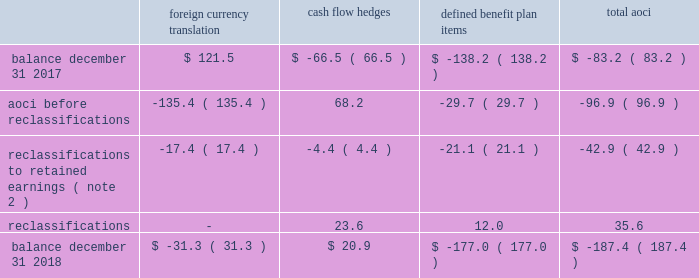Zimmer biomet holdings , inc .
And subsidiaries 2018 form 10-k annual report notes to consolidated financial statements ( continued ) default for unsecured financing arrangements , including , among other things , limitations on consolidations , mergers and sales of assets .
Financial covenants under the 2018 , 2016 and 2014 credit agreements include a consolidated indebtedness to consolidated ebitda ratio of no greater than 5.0 to 1.0 through june 30 , 2017 , and no greater than 4.5 to 1.0 thereafter .
If our credit rating falls below investment grade , additional restrictions would result , including restrictions on investments and payment of dividends .
We were in compliance with all covenants under the 2018 , 2016 and 2014 credit agreements as of december 31 , 2018 .
As of december 31 , 2018 , there were no borrowings outstanding under the multicurrency revolving facility .
We may , at our option , redeem our senior notes , in whole or in part , at any time upon payment of the principal , any applicable make-whole premium , and accrued and unpaid interest to the date of redemption , except that the floating rate notes due 2021 may not be redeemed until on or after march 20 , 2019 and such notes do not have any applicable make-whole premium .
In addition , we may redeem , at our option , the 2.700% ( 2.700 % ) senior notes due 2020 , the 3.375% ( 3.375 % ) senior notes due 2021 , the 3.150% ( 3.150 % ) senior notes due 2022 , the 3.700% ( 3.700 % ) senior notes due 2023 , the 3.550% ( 3.550 % ) senior notes due 2025 , the 4.250% ( 4.250 % ) senior notes due 2035 and the 4.450% ( 4.450 % ) senior notes due 2045 without any make-whole premium at specified dates ranging from one month to six months in advance of the scheduled maturity date .
The estimated fair value of our senior notes as of december 31 , 2018 , based on quoted prices for the specific securities from transactions in over-the-counter markets ( level 2 ) , was $ 7798.9 million .
The estimated fair value of japan term loan a and japan term loan b , in the aggregate , as of december 31 , 2018 , based upon publicly available market yield curves and the terms of the debt ( level 2 ) , was $ 294.7 million .
The carrying values of u.s .
Term loan b and u.s .
Term loan c approximate fair value as they bear interest at short-term variable market rates .
We entered into interest rate swap agreements which we designated as fair value hedges of underlying fixed-rate obligations on our senior notes due 2019 and 2021 .
These fair value hedges were settled in 2016 .
In 2016 , we entered into various variable-to-fixed interest rate swap agreements that were accounted for as cash flow hedges of u.s .
Term loan b .
In 2018 , we entered into cross-currency interest rate swaps that we designated as net investment hedges .
The excluded component of these net investment hedges is recorded in interest expense , net .
See note 13 for additional information regarding our interest rate swap agreements .
We also have available uncommitted credit facilities totaling $ 55.0 million .
At december 31 , 2018 and 2017 , the weighted average interest rate for our borrowings was 3.1 percent and 2.9 percent , respectively .
We paid $ 282.8 million , $ 317.5 million , and $ 363.1 million in interest during 2018 , 2017 , and 2016 , respectively .
12 .
Accumulated other comprehensive ( loss ) income aoci refers to certain gains and losses that under gaap are included in comprehensive income but are excluded from net earnings as these amounts are initially recorded as an adjustment to stockholders 2019 equity .
Amounts in aoci may be reclassified to net earnings upon the occurrence of certain events .
Our aoci is comprised of foreign currency translation adjustments , including unrealized gains and losses on net investment hedges , unrealized gains and losses on cash flow hedges , and amortization of prior service costs and unrecognized gains and losses in actuarial assumptions on our defined benefit plans .
Foreign currency translation adjustments are reclassified to net earnings upon sale or upon a complete or substantially complete liquidation of an investment in a foreign entity .
Unrealized gains and losses on cash flow hedges are reclassified to net earnings when the hedged item affects net earnings .
Amounts related to defined benefit plans that are in aoci are reclassified over the service periods of employees in the plan .
See note 14 for more information on our defined benefit plans .
The table shows the changes in the components of aoci , net of tax ( in millions ) : foreign currency translation hedges defined benefit plan items .

What is the percent change in the balance of foreign currency translation between 2017 and 2018? 
Rationale: it says invalid but ( ) means -
Computations: ((31.3 * const_m1) - 121.5)
Answer: -152.8. 